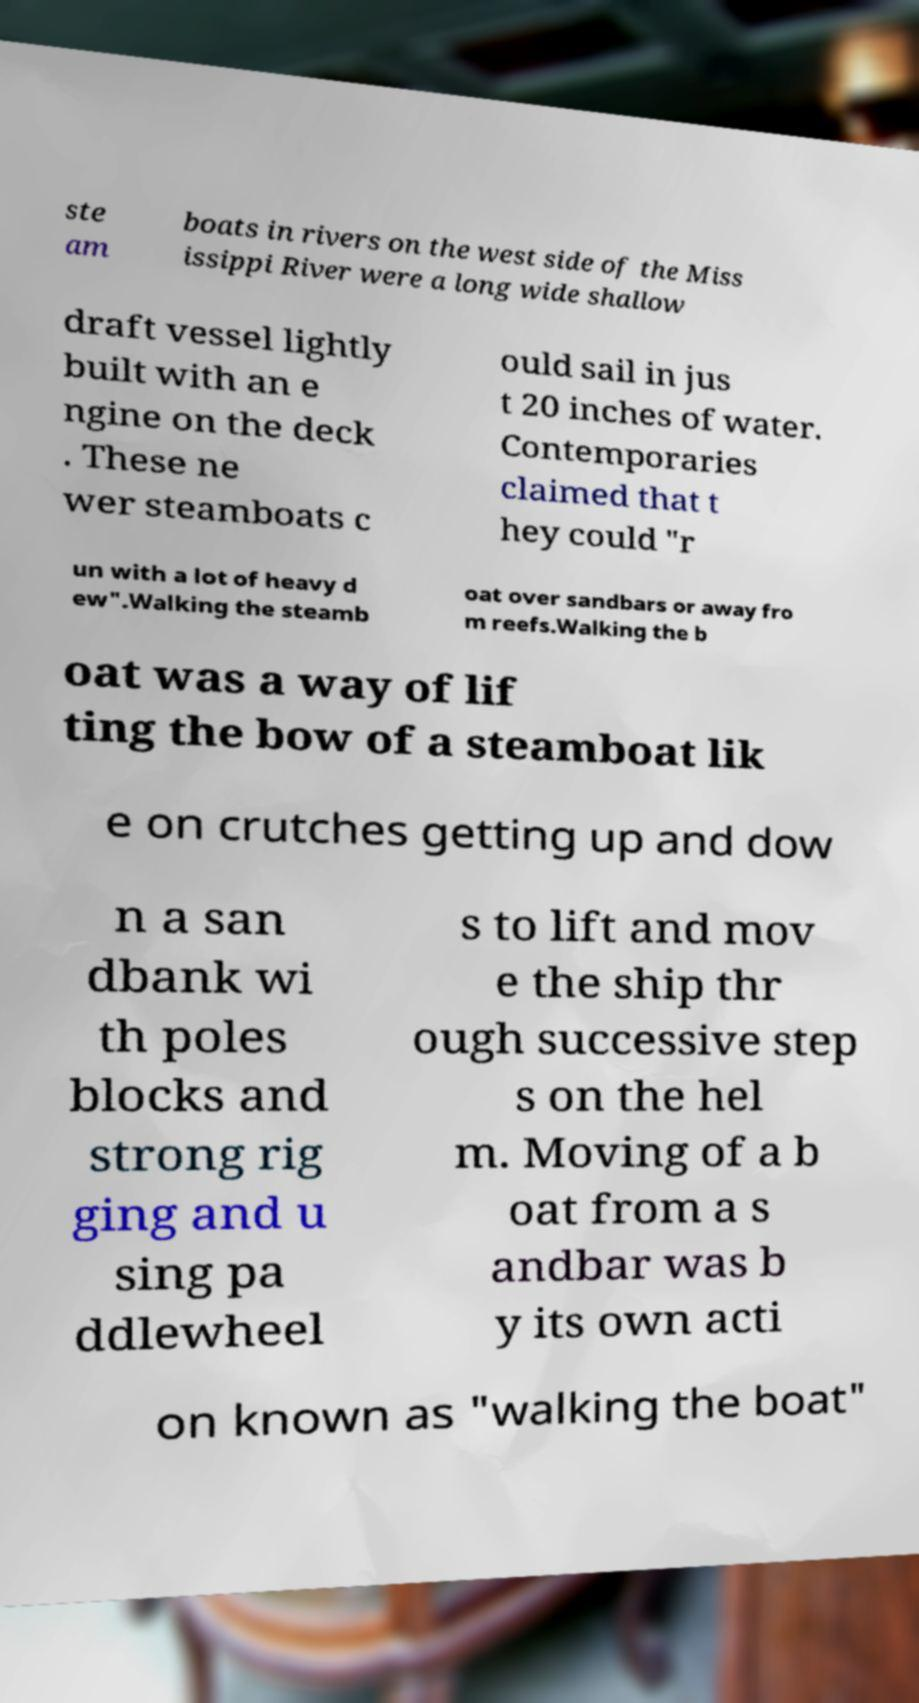There's text embedded in this image that I need extracted. Can you transcribe it verbatim? ste am boats in rivers on the west side of the Miss issippi River were a long wide shallow draft vessel lightly built with an e ngine on the deck . These ne wer steamboats c ould sail in jus t 20 inches of water. Contemporaries claimed that t hey could "r un with a lot of heavy d ew".Walking the steamb oat over sandbars or away fro m reefs.Walking the b oat was a way of lif ting the bow of a steamboat lik e on crutches getting up and dow n a san dbank wi th poles blocks and strong rig ging and u sing pa ddlewheel s to lift and mov e the ship thr ough successive step s on the hel m. Moving of a b oat from a s andbar was b y its own acti on known as "walking the boat" 